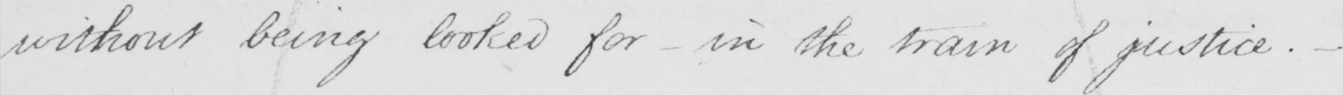What text is written in this handwritten line? without being looked for  _  in the train of justice .  _ 